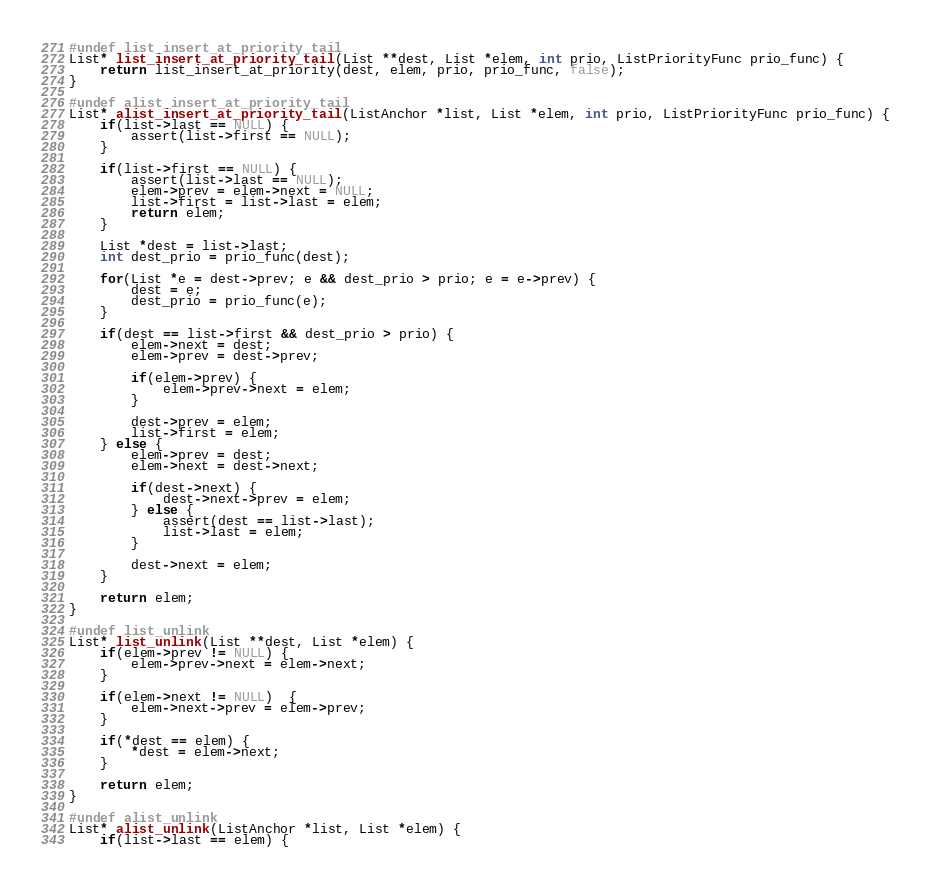<code> <loc_0><loc_0><loc_500><loc_500><_C_>#undef list_insert_at_priority_tail
List* list_insert_at_priority_tail(List **dest, List *elem, int prio, ListPriorityFunc prio_func) {
	return list_insert_at_priority(dest, elem, prio, prio_func, false);
}

#undef alist_insert_at_priority_tail
List* alist_insert_at_priority_tail(ListAnchor *list, List *elem, int prio, ListPriorityFunc prio_func) {
	if(list->last == NULL) {
		assert(list->first == NULL);
	}

	if(list->first == NULL) {
		assert(list->last == NULL);
		elem->prev = elem->next = NULL;
		list->first = list->last = elem;
		return elem;
	}

	List *dest = list->last;
	int dest_prio = prio_func(dest);

	for(List *e = dest->prev; e && dest_prio > prio; e = e->prev) {
		dest = e;
		dest_prio = prio_func(e);
	}

	if(dest == list->first && dest_prio > prio) {
		elem->next = dest;
		elem->prev = dest->prev;

		if(elem->prev) {
			elem->prev->next = elem;
		}

		dest->prev = elem;
		list->first = elem;
	} else {
		elem->prev = dest;
		elem->next = dest->next;

		if(dest->next) {
			dest->next->prev = elem;
		} else {
			assert(dest == list->last);
			list->last = elem;
		}

		dest->next = elem;
	}

	return elem;
}

#undef list_unlink
List* list_unlink(List **dest, List *elem) {
	if(elem->prev != NULL) {
		elem->prev->next = elem->next;
	}

	if(elem->next != NULL)  {
		elem->next->prev = elem->prev;
	}

	if(*dest == elem) {
		*dest = elem->next;
	}

	return elem;
}

#undef alist_unlink
List* alist_unlink(ListAnchor *list, List *elem) {
	if(list->last == elem) {</code> 